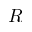<formula> <loc_0><loc_0><loc_500><loc_500>R</formula> 